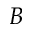Convert formula to latex. <formula><loc_0><loc_0><loc_500><loc_500>B</formula> 